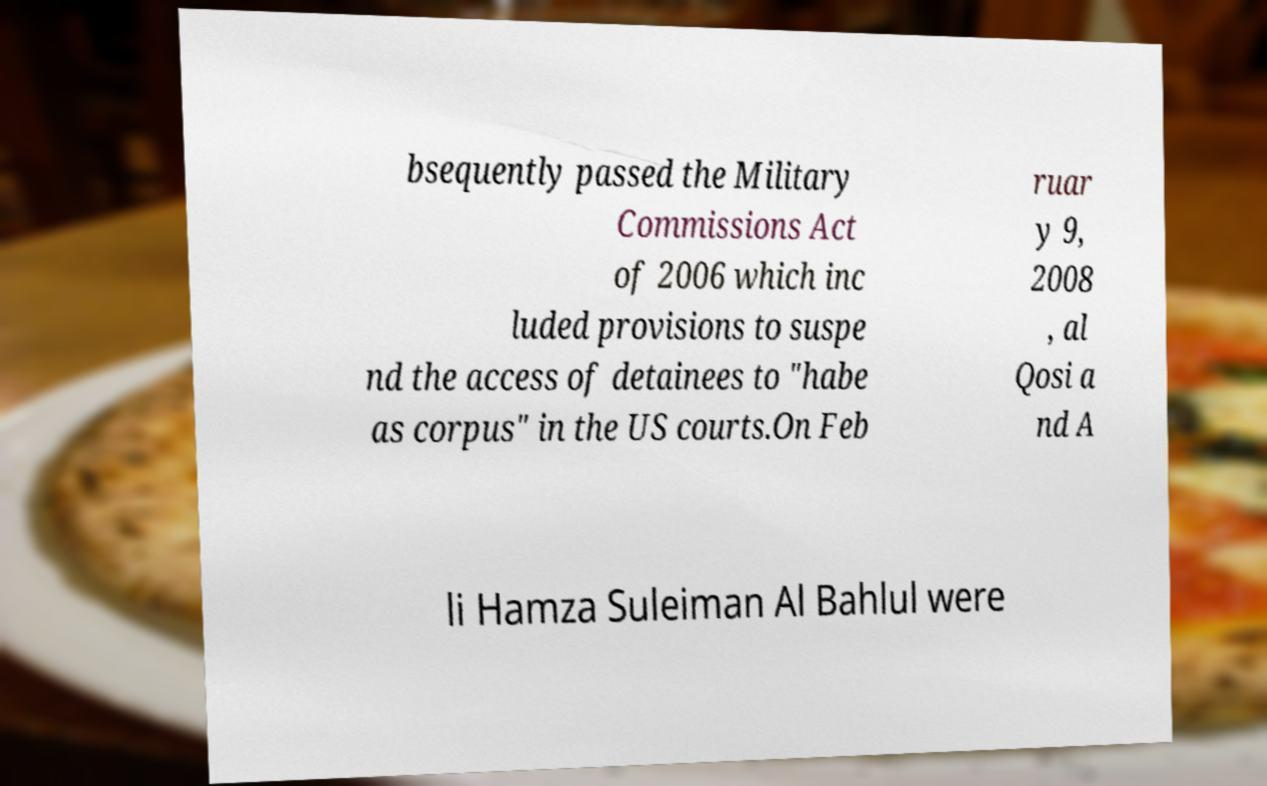Could you extract and type out the text from this image? bsequently passed the Military Commissions Act of 2006 which inc luded provisions to suspe nd the access of detainees to "habe as corpus" in the US courts.On Feb ruar y 9, 2008 , al Qosi a nd A li Hamza Suleiman Al Bahlul were 